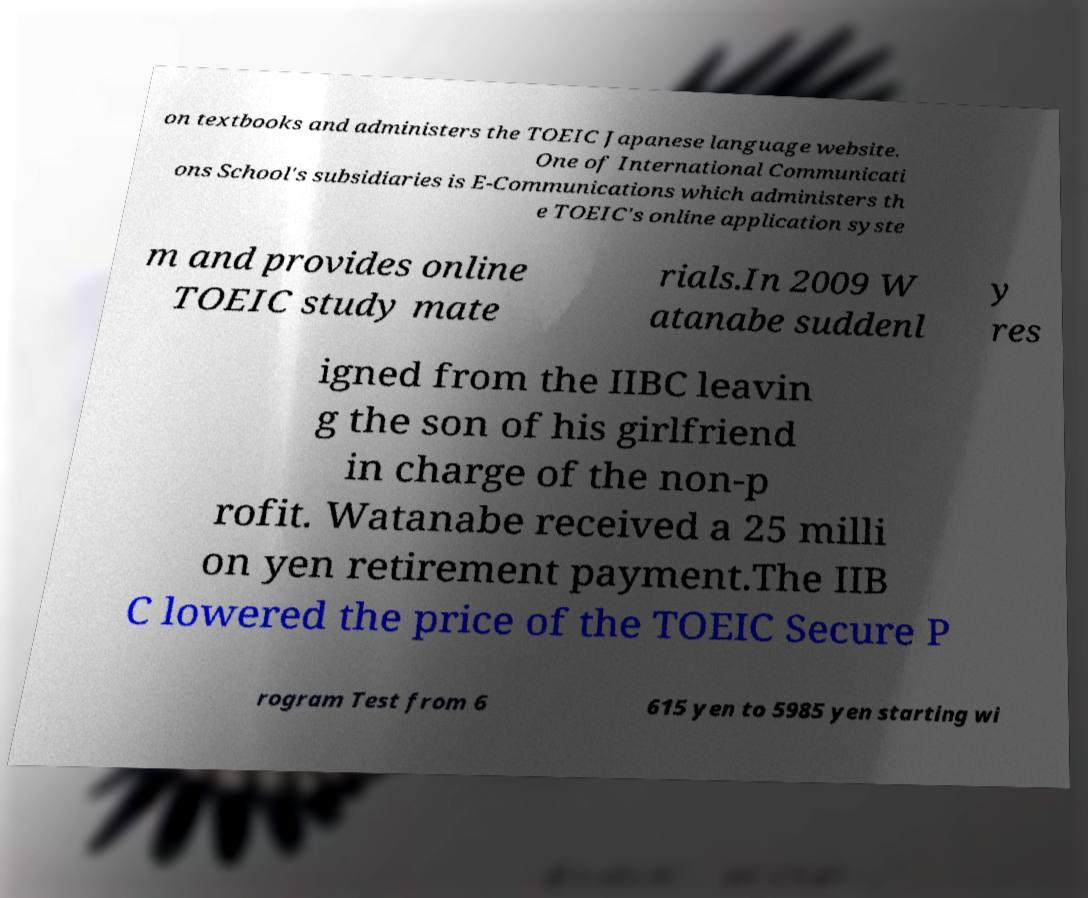Please identify and transcribe the text found in this image. on textbooks and administers the TOEIC Japanese language website. One of International Communicati ons School's subsidiaries is E-Communications which administers th e TOEIC's online application syste m and provides online TOEIC study mate rials.In 2009 W atanabe suddenl y res igned from the IIBC leavin g the son of his girlfriend in charge of the non-p rofit. Watanabe received a 25 milli on yen retirement payment.The IIB C lowered the price of the TOEIC Secure P rogram Test from 6 615 yen to 5985 yen starting wi 